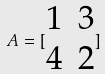Convert formula to latex. <formula><loc_0><loc_0><loc_500><loc_500>A = [ \begin{matrix} 1 & 3 \\ 4 & 2 \end{matrix} ]</formula> 